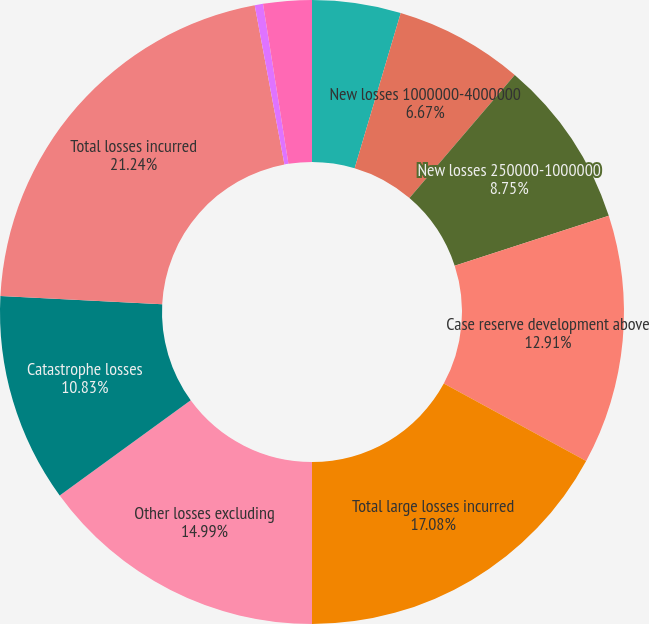Convert chart to OTSL. <chart><loc_0><loc_0><loc_500><loc_500><pie_chart><fcel>New losses greater than<fcel>New losses 1000000-4000000<fcel>New losses 250000-1000000<fcel>Case reserve development above<fcel>Total large losses incurred<fcel>Other losses excluding<fcel>Catastrophe losses<fcel>Total losses incurred<fcel>Total large loss ratio<fcel>Total loss ratio<nl><fcel>4.59%<fcel>6.67%<fcel>8.75%<fcel>12.91%<fcel>17.08%<fcel>14.99%<fcel>10.83%<fcel>21.24%<fcel>0.43%<fcel>2.51%<nl></chart> 